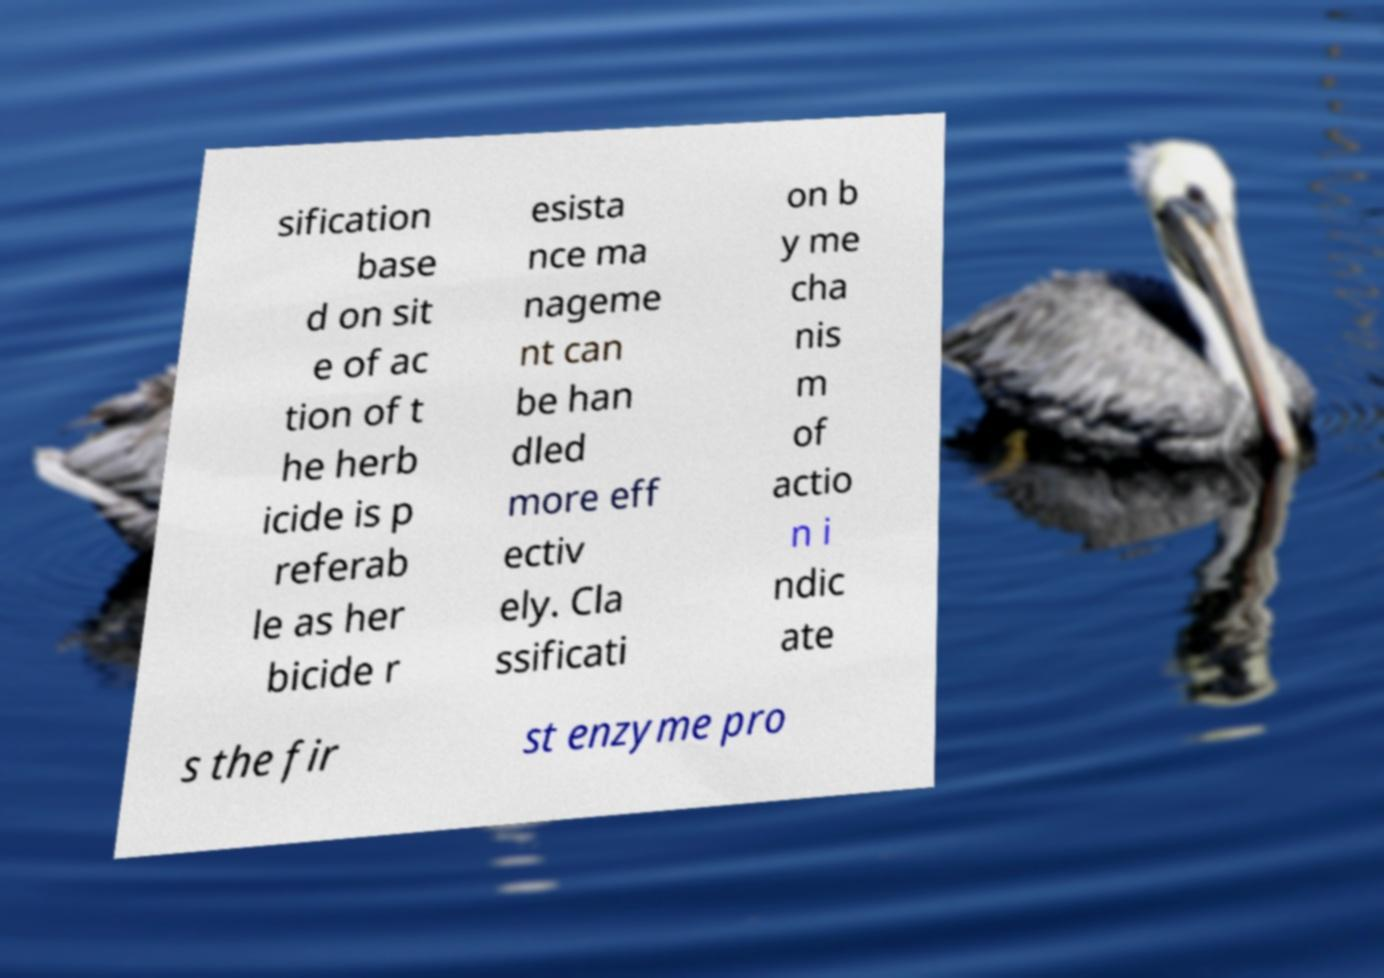I need the written content from this picture converted into text. Can you do that? sification base d on sit e of ac tion of t he herb icide is p referab le as her bicide r esista nce ma nageme nt can be han dled more eff ectiv ely. Cla ssificati on b y me cha nis m of actio n i ndic ate s the fir st enzyme pro 